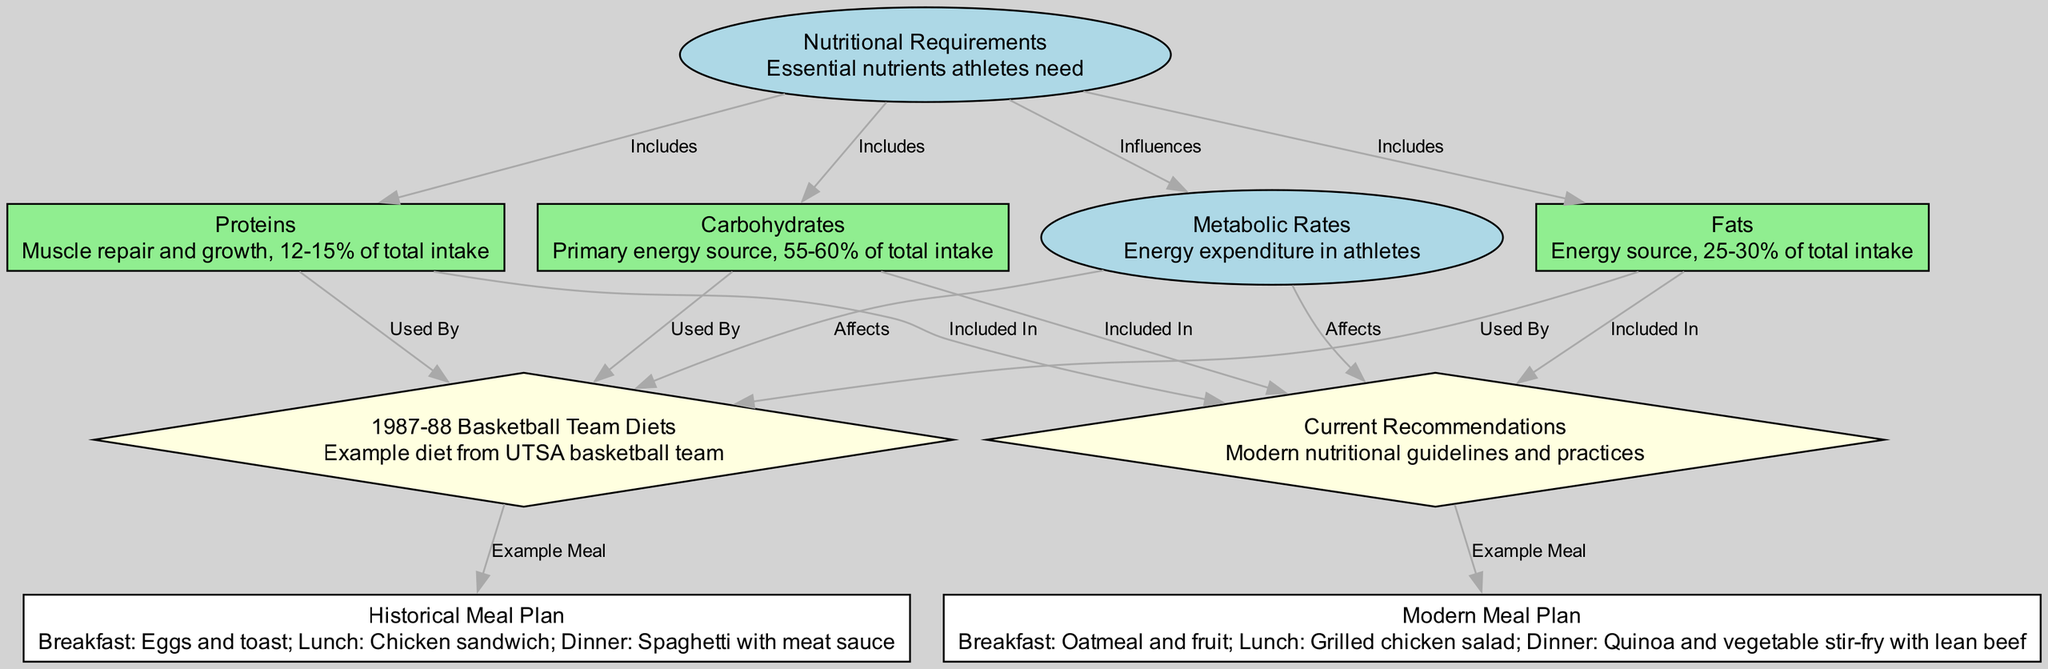What are the primary nutrients included in nutritional requirements? The diagram clearly indicates that carbohydrates, proteins, and fats are included under nutritional requirements, showing their significance for athletes.
Answer: carbohydrates, proteins, fats How many edges are displayed in the diagram? By counting the connections between nodes (arrows), we find there are a total of 13 edges illustrated in the diagram.
Answer: 13 What is the energy source that constitutes 25-30% of total intake? The node labeled "Fats" specifically states it is an energy source that comprises 25-30% of total intake, highlighting its role in nutrition for athletes.
Answer: Fats Which meal is an example from the 1987-88 basketball team diets? The node "Historical Meal Plan" outlines the example meal plan showing breakfast of eggs and toast, along with lunch and dinner options, representing the historical diet effectively.
Answer: Breakfast: Eggs and toast How do metabolic rates affect dietary recommendations? The diagram explicitly connects "Metabolic Rates" to both "Historical Diets" and "Current Recommendations" indicating that energy expenditure impacts what athletes should eat in both historical and modern contexts.
Answer: Affects Which nutrients are included in the current recommendations? The graph shows that carbohydrates, proteins, and fats are included in current recommendations, matching the nutritional requirements athletes need today.
Answer: carbohydrates, proteins, fats How many nodes are connected from "Nutritional Requirements"? There are three nodes connected: carbohydrates, proteins, and fats, demonstrating how these nutrients originate from the broader category of nutritional requirements for athletes.
Answer: 3 What is one modern meal example outlined in the diagram? The node "Modern Meal Plan" mentions an example breakfast of oatmeal and fruit, representing a current recommendation for what athletes should consume.
Answer: Breakfast: Oatmeal and fruit What percentage of total intake do carbohydrates constitute? The diagram informs us that carbohydrates make up 55-60% of total intake, laying out important dietary information for athletes.
Answer: 55-60% 